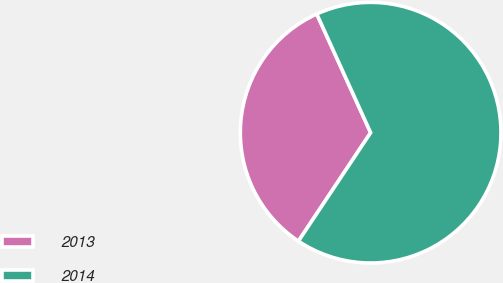Convert chart. <chart><loc_0><loc_0><loc_500><loc_500><pie_chart><fcel>2013<fcel>2014<nl><fcel>33.87%<fcel>66.13%<nl></chart> 